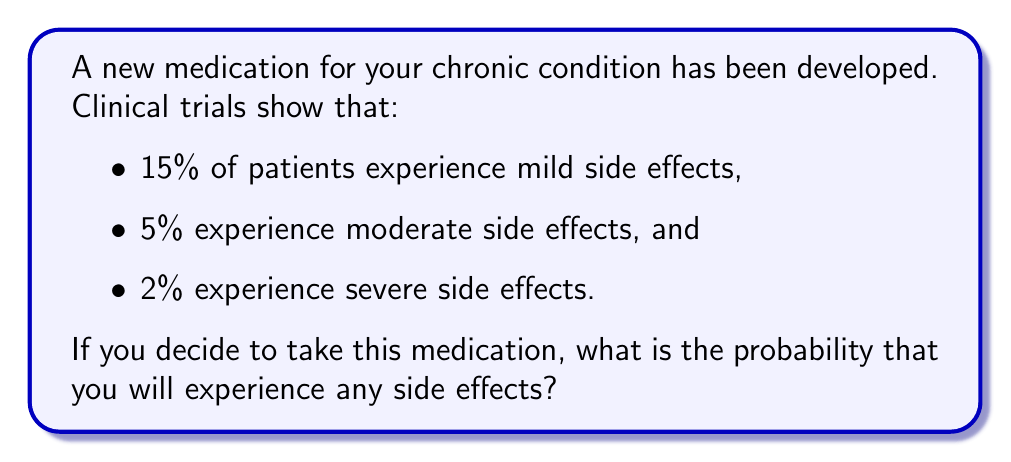Can you solve this math problem? Let's approach this step-by-step using probability theory:

1) First, we need to identify the events:
   A: experiencing mild side effects
   B: experiencing moderate side effects
   C: experiencing severe side effects

2) We're given the probabilities for each event:
   $P(A) = 0.15$
   $P(B) = 0.05$
   $P(C) = 0.02$

3) We want to find the probability of experiencing any side effects. This is equivalent to the probability of A or B or C occurring.

4) In probability theory, we can use the addition rule for this. However, we need to be careful about potential overlaps (e.g., a patient might experience both mild and moderate side effects).

5) To account for all possibilities without double-counting, we use the inclusion-exclusion principle:

   $P(A \cup B \cup C) = P(A) + P(B) + P(C) - P(A \cap B) - P(A \cap C) - P(B \cap C) + P(A \cap B \cap C)$

6) However, we don't have information about the intersections of these events. In the absence of this information, we can assume the events are mutually exclusive (i.e., they cannot occur simultaneously).

7) Under this assumption, all the intersection terms become zero, and our equation simplifies to:

   $P(A \cup B \cup C) = P(A) + P(B) + P(C)$

8) Now we can substitute the given probabilities:

   $P(\text{any side effects}) = 0.15 + 0.05 + 0.02 = 0.22$

Therefore, the probability of experiencing any side effects is 0.22 or 22%.
Answer: 0.22 